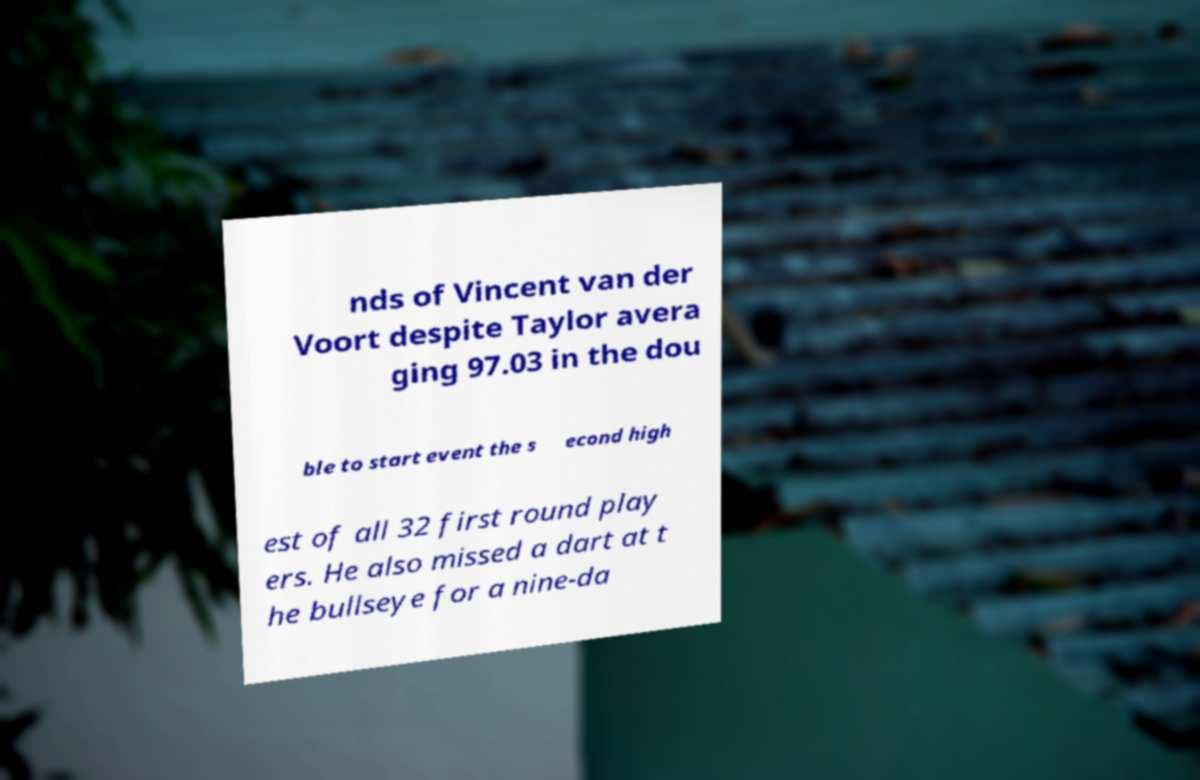Please identify and transcribe the text found in this image. nds of Vincent van der Voort despite Taylor avera ging 97.03 in the dou ble to start event the s econd high est of all 32 first round play ers. He also missed a dart at t he bullseye for a nine-da 